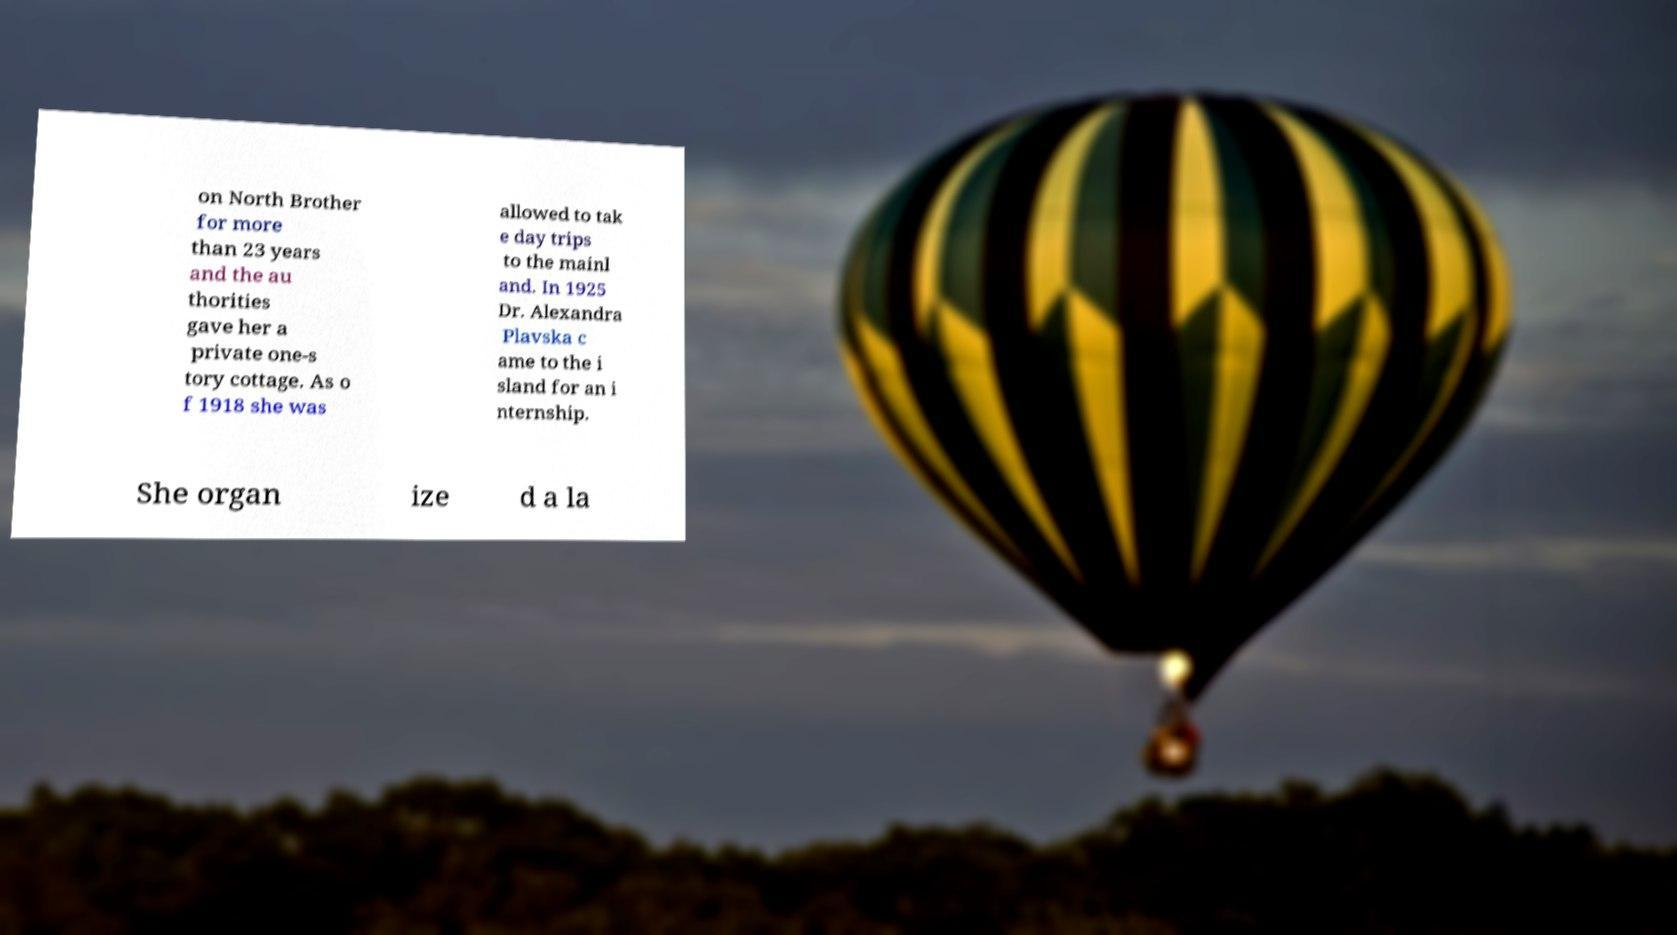Please identify and transcribe the text found in this image. on North Brother for more than 23 years and the au thorities gave her a private one-s tory cottage. As o f 1918 she was allowed to tak e day trips to the mainl and. In 1925 Dr. Alexandra Plavska c ame to the i sland for an i nternship. She organ ize d a la 